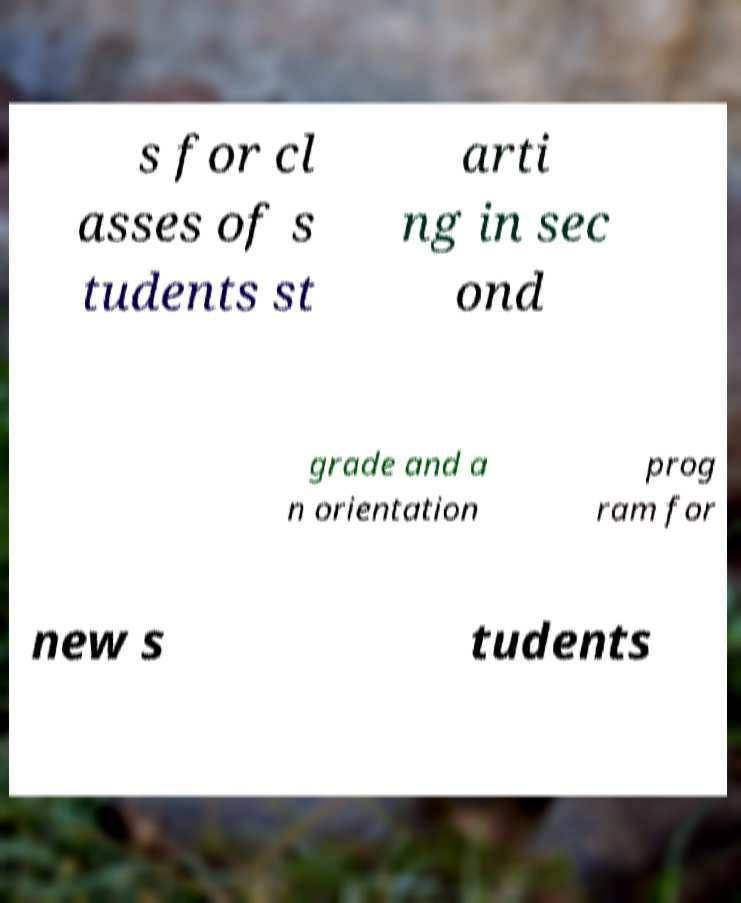There's text embedded in this image that I need extracted. Can you transcribe it verbatim? s for cl asses of s tudents st arti ng in sec ond grade and a n orientation prog ram for new s tudents 